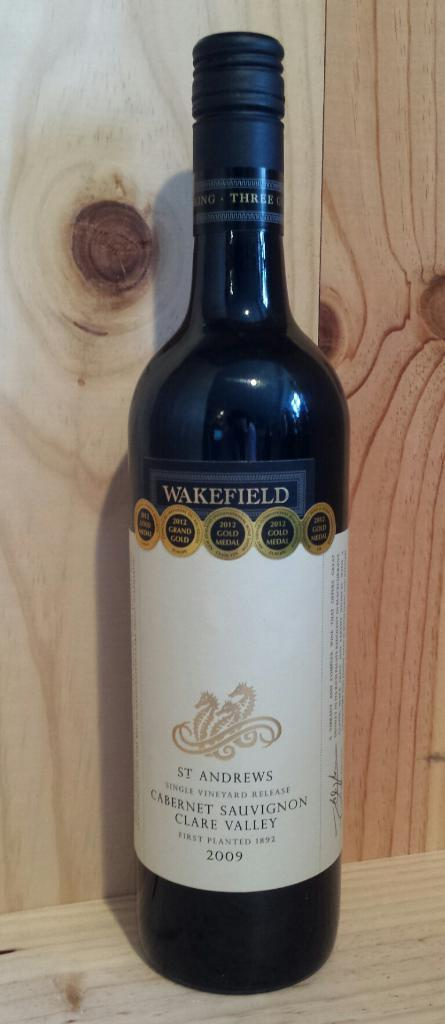<image>
Offer a succinct explanation of the picture presented. A bottle of classic Wakefield made in 2009 